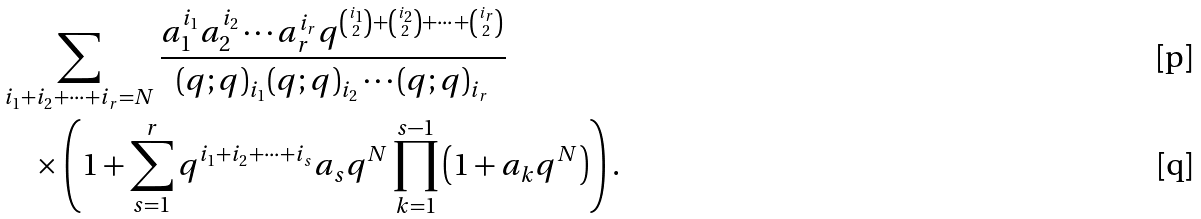<formula> <loc_0><loc_0><loc_500><loc_500>& \sum _ { i _ { 1 } + i _ { 2 } + \cdots + i _ { r } = N } \frac { a _ { 1 } ^ { i _ { 1 } } a _ { 2 } ^ { i _ { 2 } } \cdots a _ { r } ^ { i _ { r } } q ^ { \binom { i _ { 1 } } { 2 } + \binom { i _ { 2 } } { 2 } + \cdots + \binom { i _ { r } } { 2 } } } { ( q ; q ) _ { i _ { 1 } } ( q ; q ) _ { i _ { 2 } } \cdots ( q ; q ) _ { i _ { r } } } \\ & \quad \times \left ( 1 + \sum _ { s = 1 } ^ { r } q ^ { i _ { 1 } + i _ { 2 } + \cdots + i _ { s } } a _ { s } q ^ { N } \prod _ { k = 1 } ^ { s - 1 } \left ( 1 + a _ { k } q ^ { N } \right ) \right ) .</formula> 